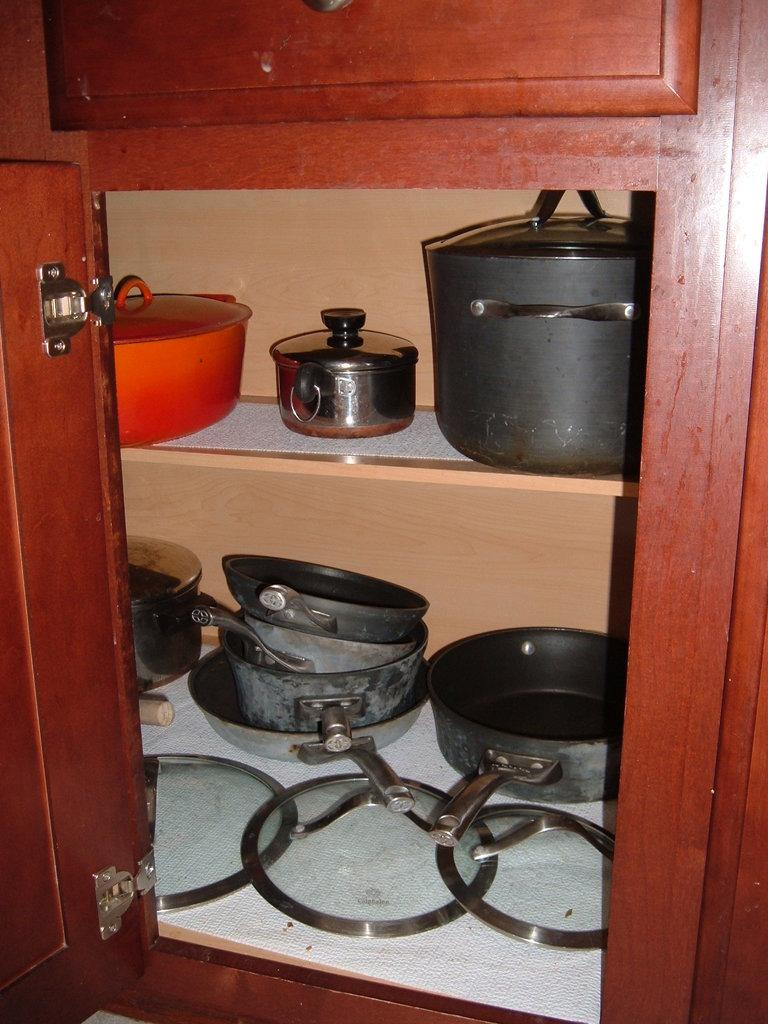What type of furniture is present in the image? There is a cupboard in the image. What can be found inside the cupboard? Inside the cupboard, there are pans and other vessels. What is the distance between the cupboard and the gun in the image? There is no gun present in the image, so it is not possible to determine the distance between the cupboard and a gun. 